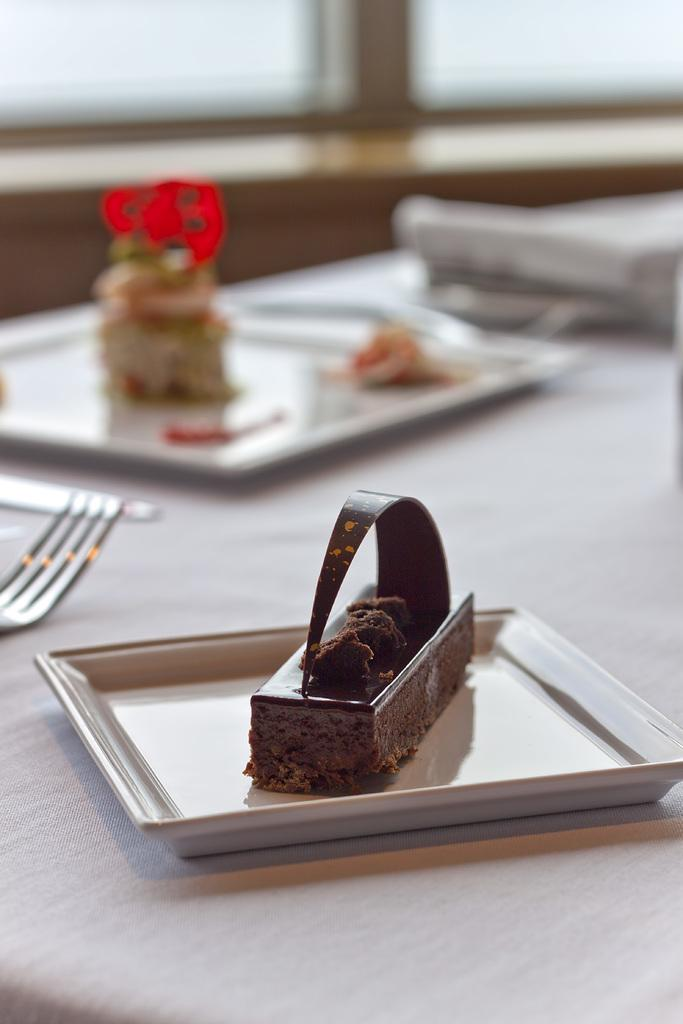What is on the plate that is on the table in the image? There is a cake on a plate on the table in the image. What else can be seen on the table? There is a plate with food items and a fork on the table. Can you describe the background of the image? There is a wall and a window in the background of the image. What might be used to eat the food items on the table? The fork on the table can be used to eat the food items. What hobbies do the boys engage in while playing with the doll in the image? There are no boys or dolls present in the image; it features a cake, food items, and tableware on a table with a wall and window in the background. 